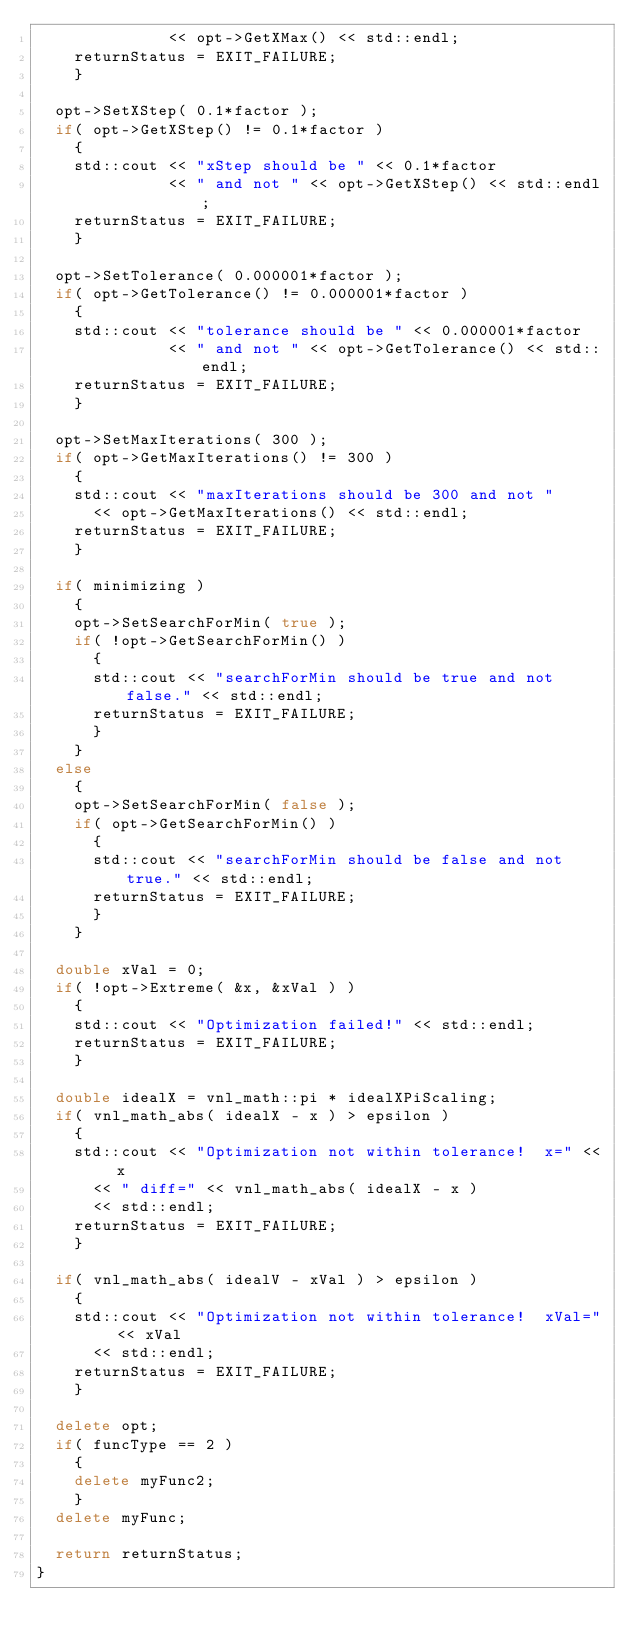<code> <loc_0><loc_0><loc_500><loc_500><_C++_>              << opt->GetXMax() << std::endl;
    returnStatus = EXIT_FAILURE;
    }

  opt->SetXStep( 0.1*factor );
  if( opt->GetXStep() != 0.1*factor )
    {
    std::cout << "xStep should be " << 0.1*factor
              << " and not " << opt->GetXStep() << std::endl;
    returnStatus = EXIT_FAILURE;
    }

  opt->SetTolerance( 0.000001*factor );
  if( opt->GetTolerance() != 0.000001*factor )
    {
    std::cout << "tolerance should be " << 0.000001*factor
              << " and not " << opt->GetTolerance() << std::endl;
    returnStatus = EXIT_FAILURE;
    }

  opt->SetMaxIterations( 300 );
  if( opt->GetMaxIterations() != 300 )
    {
    std::cout << "maxIterations should be 300 and not "
      << opt->GetMaxIterations() << std::endl;
    returnStatus = EXIT_FAILURE;
    }

  if( minimizing )
    {
    opt->SetSearchForMin( true );
    if( !opt->GetSearchForMin() )
      {
      std::cout << "searchForMin should be true and not false." << std::endl;
      returnStatus = EXIT_FAILURE;
      }
    }
  else
    {
    opt->SetSearchForMin( false );
    if( opt->GetSearchForMin() )
      {
      std::cout << "searchForMin should be false and not true." << std::endl;
      returnStatus = EXIT_FAILURE;
      }
    }

  double xVal = 0;
  if( !opt->Extreme( &x, &xVal ) )
    {
    std::cout << "Optimization failed!" << std::endl;
    returnStatus = EXIT_FAILURE;
    }

  double idealX = vnl_math::pi * idealXPiScaling;
  if( vnl_math_abs( idealX - x ) > epsilon )
    {
    std::cout << "Optimization not within tolerance!  x=" << x
      << " diff=" << vnl_math_abs( idealX - x )
      << std::endl;
    returnStatus = EXIT_FAILURE;
    }

  if( vnl_math_abs( idealV - xVal ) > epsilon )
    {
    std::cout << "Optimization not within tolerance!  xVal=" << xVal
      << std::endl;
    returnStatus = EXIT_FAILURE;
    }

  delete opt;
  if( funcType == 2 )
    {
    delete myFunc2;
    }
  delete myFunc;

  return returnStatus;
}
</code> 